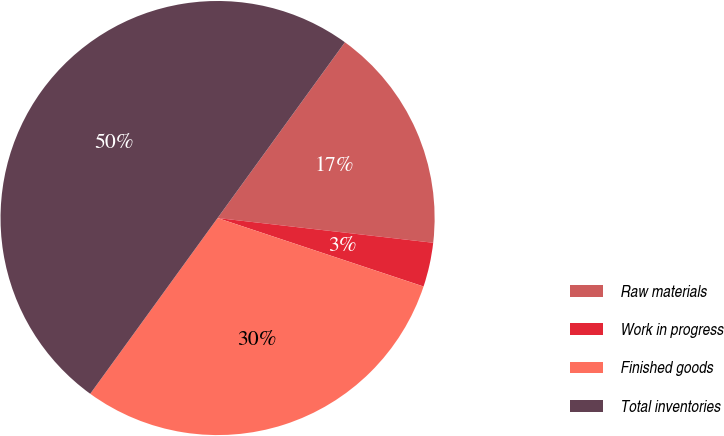Convert chart. <chart><loc_0><loc_0><loc_500><loc_500><pie_chart><fcel>Raw materials<fcel>Work in progress<fcel>Finished goods<fcel>Total inventories<nl><fcel>16.84%<fcel>3.29%<fcel>29.87%<fcel>50.0%<nl></chart> 